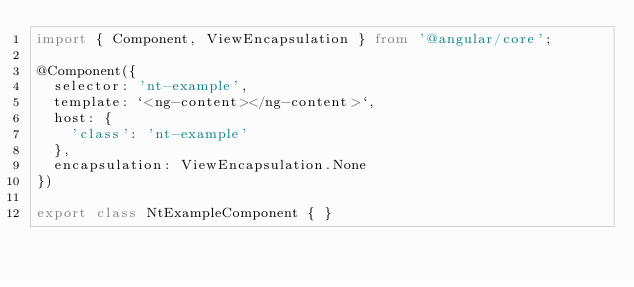<code> <loc_0><loc_0><loc_500><loc_500><_TypeScript_>import { Component, ViewEncapsulation } from '@angular/core';

@Component({
  selector: 'nt-example',
  template: `<ng-content></ng-content>`,
  host: {
    'class': 'nt-example'
  },
  encapsulation: ViewEncapsulation.None
})

export class NtExampleComponent { }
</code> 